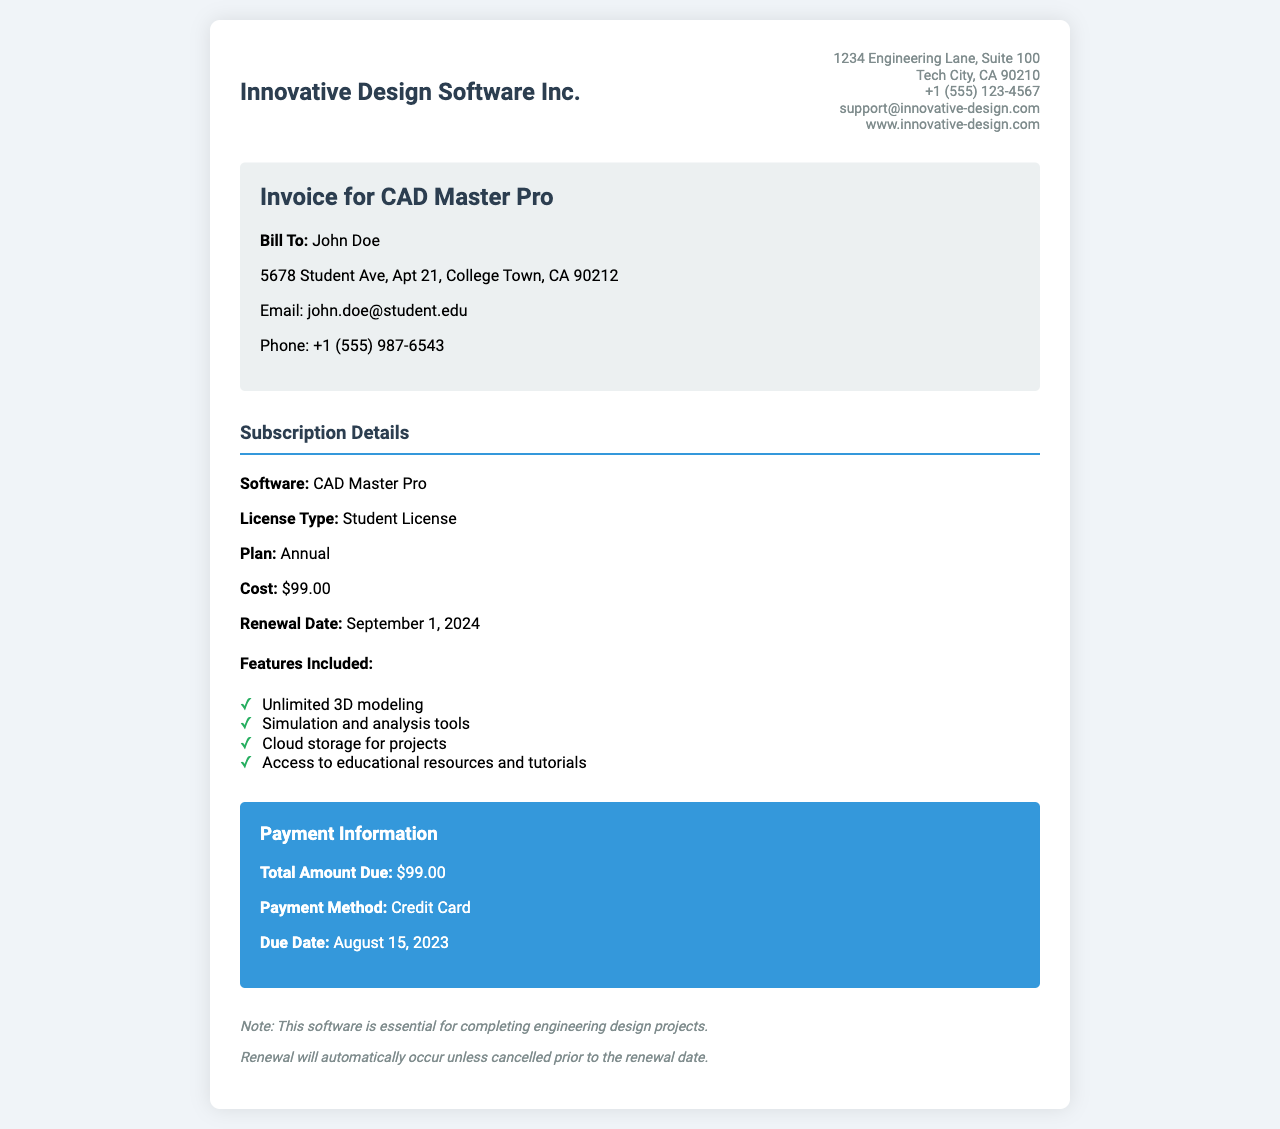What is the total amount due? The total amount due is clearly stated in the payment information section as $99.00.
Answer: $99.00 Who is the bill to? The document specifies that the bill is addressed to John Doe.
Answer: John Doe What is the renewal date? The subscription details section mentions that the renewal date is September 1, 2024.
Answer: September 1, 2024 What type of license is this? The license type for the software is stated as a Student License.
Answer: Student License How much does the software cost? The cost of the software is mentioned as $99.00.
Answer: $99.00 What payment method is used? The document indicates that the payment method is a Credit Card.
Answer: Credit Card What is included in the features list? The features included highlight several benefits like unlimited 3D modeling and cloud storage.
Answer: Unlimited 3D modeling, Simulation and analysis tools, Cloud storage for projects, Access to educational resources and tutorials What is the due date for payment? The payment information section specifies that the due date is August 15, 2023.
Answer: August 15, 2023 What is the name of the software? The software name mentioned in the invoice is CAD Master Pro.
Answer: CAD Master Pro 